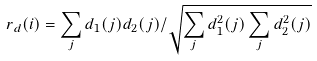Convert formula to latex. <formula><loc_0><loc_0><loc_500><loc_500>r _ { d } ( i ) = \sum _ { j } d _ { 1 } ( j ) d _ { 2 } ( j ) / \sqrt { \sum _ { j } d _ { 1 } ^ { 2 } ( j ) \sum _ { j } d _ { 2 } ^ { 2 } ( j ) }</formula> 